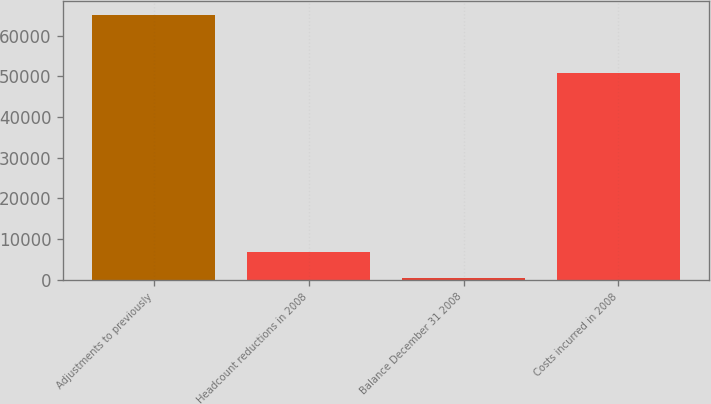Convert chart to OTSL. <chart><loc_0><loc_0><loc_500><loc_500><bar_chart><fcel>Adjustments to previously<fcel>Headcount reductions in 2008<fcel>Balance December 31 2008<fcel>Costs incurred in 2008<nl><fcel>65152<fcel>6920.2<fcel>450<fcel>50856<nl></chart> 